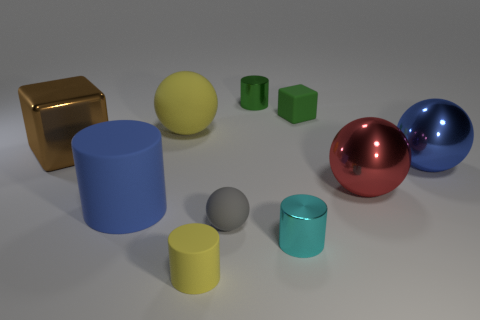Is the tiny cylinder on the right side of the tiny green cylinder made of the same material as the brown block? Based on the image, it appears that the tiny cylinder has a matte finish similar to the green cylinder, suggesting that they could be made of the same material. However, the brown block has a reflective metallic finish, which is quite distinct from the tiny cylinder's surface texture. Therefore, it is unlikely that the tiny cylinder and the brown block are made of the same material. 